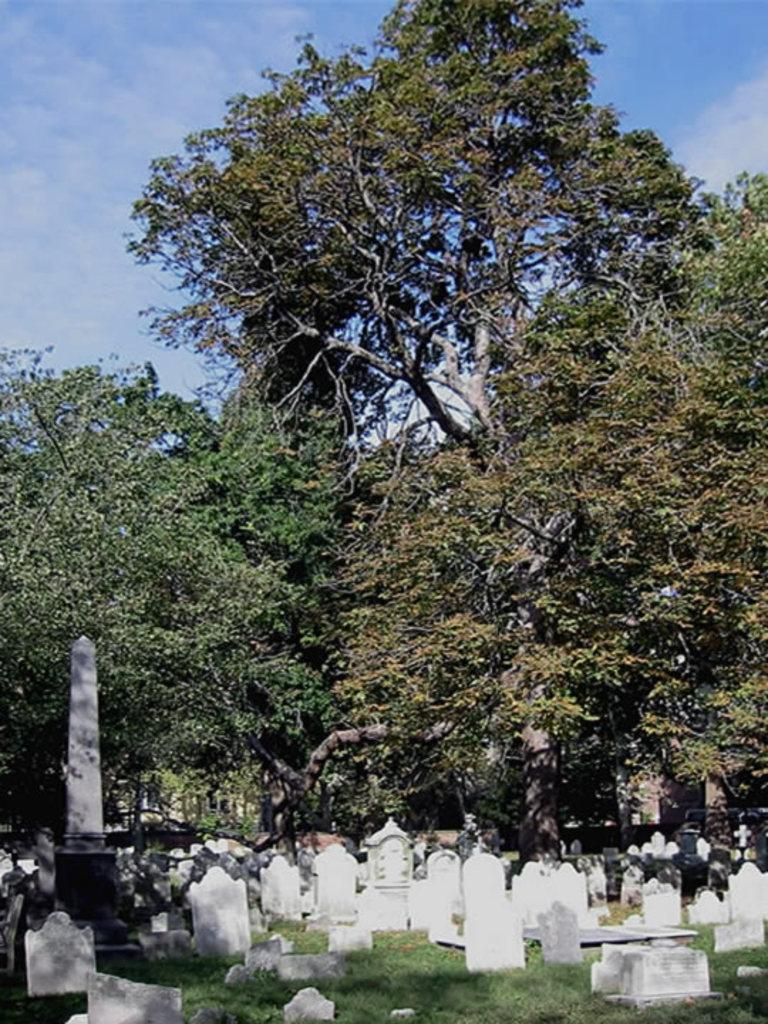What type of objects can be seen in the image? There are gravestones in the image. What is the ground surface like in the image? There is grass visible in the image. What type of vegetation is present in the image? There are trees in the image. What can be seen in the background of the image? The sky is visible in the background of the image. What type of doll is sitting on the scarecrow in the image? There is no doll or scarecrow present in the image; it features gravestones, grass, trees, and the sky. 